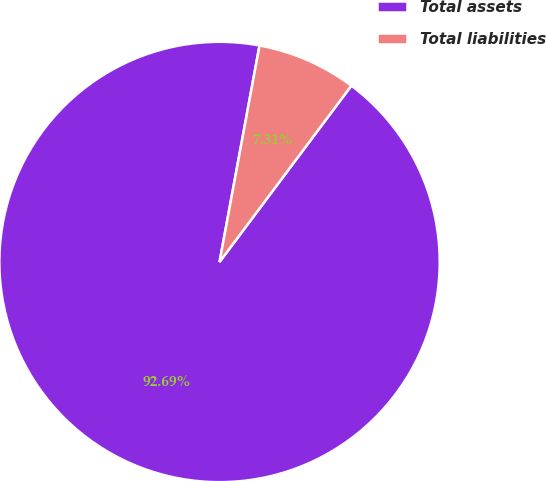Convert chart. <chart><loc_0><loc_0><loc_500><loc_500><pie_chart><fcel>Total assets<fcel>Total liabilities<nl><fcel>92.69%<fcel>7.31%<nl></chart> 